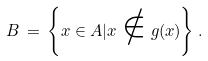<formula> <loc_0><loc_0><loc_500><loc_500>B \, = \, \left \{ x \in A | x \notin g ( x ) \right \} .</formula> 